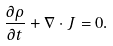<formula> <loc_0><loc_0><loc_500><loc_500>\frac { \partial \rho } { \partial t } + \nabla \cdot J = 0 .</formula> 